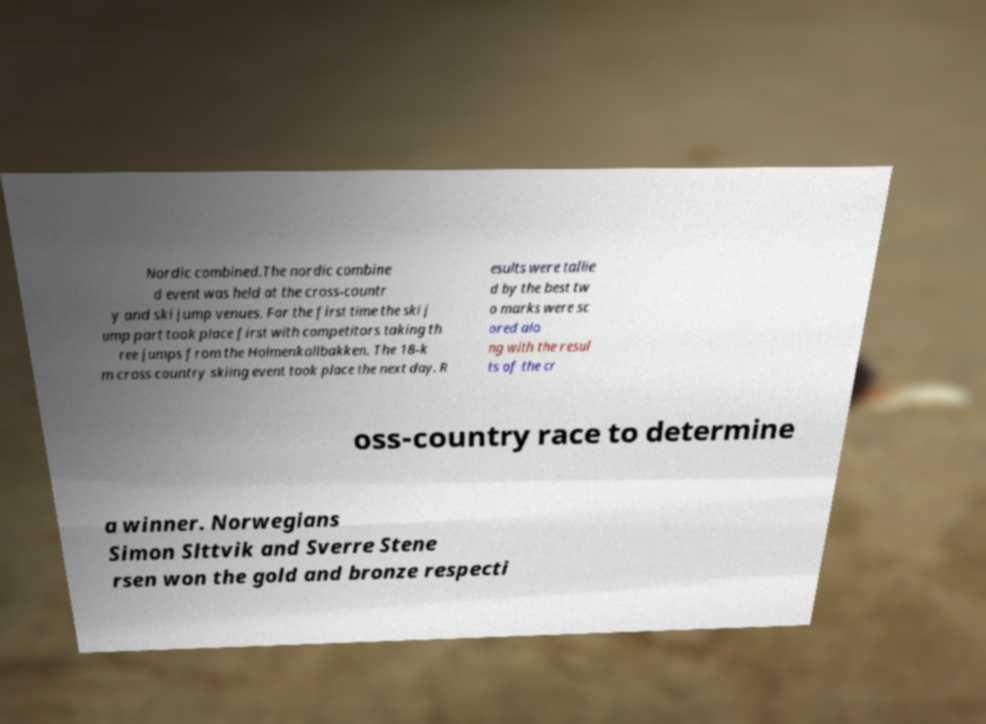Please identify and transcribe the text found in this image. Nordic combined.The nordic combine d event was held at the cross-countr y and ski jump venues. For the first time the ski j ump part took place first with competitors taking th ree jumps from the Holmenkollbakken. The 18-k m cross country skiing event took place the next day. R esults were tallie d by the best tw o marks were sc ored alo ng with the resul ts of the cr oss-country race to determine a winner. Norwegians Simon Slttvik and Sverre Stene rsen won the gold and bronze respecti 